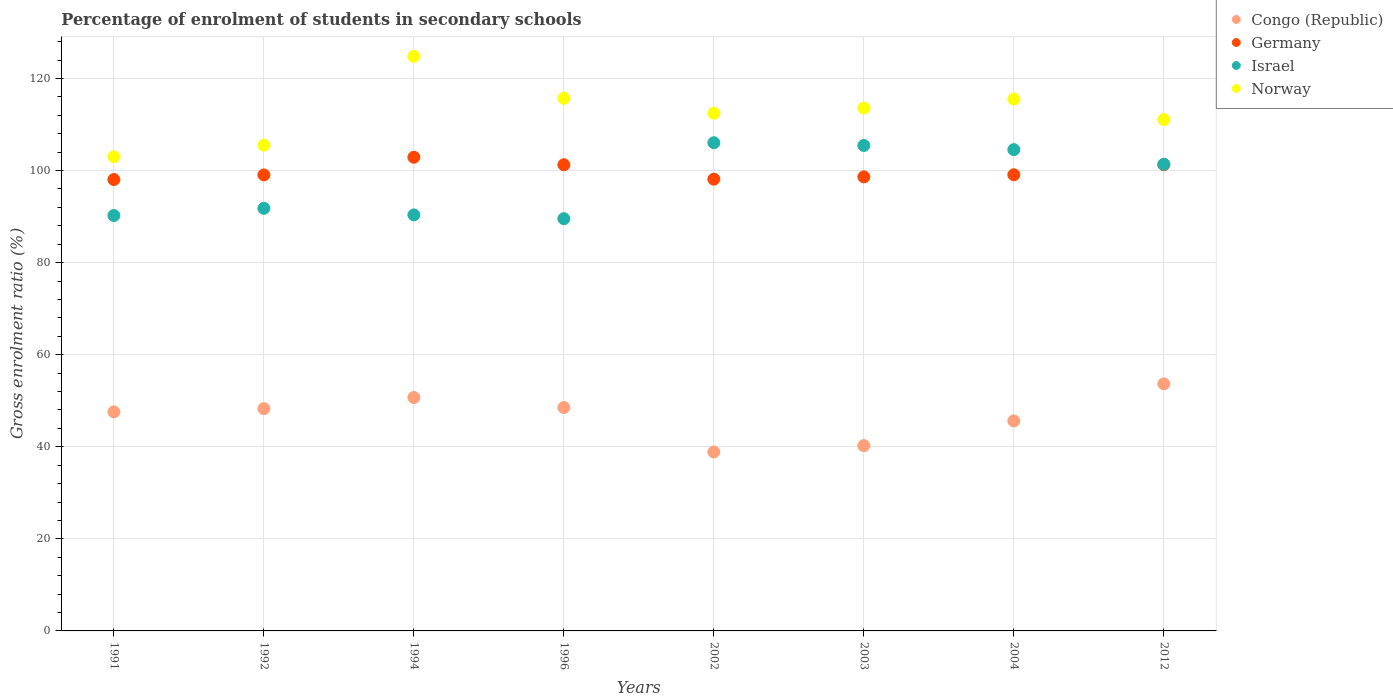What is the percentage of students enrolled in secondary schools in Germany in 1991?
Provide a succinct answer. 98.04. Across all years, what is the maximum percentage of students enrolled in secondary schools in Norway?
Offer a terse response. 124.79. Across all years, what is the minimum percentage of students enrolled in secondary schools in Congo (Republic)?
Make the answer very short. 38.87. In which year was the percentage of students enrolled in secondary schools in Israel minimum?
Make the answer very short. 1996. What is the total percentage of students enrolled in secondary schools in Congo (Republic) in the graph?
Make the answer very short. 373.46. What is the difference between the percentage of students enrolled in secondary schools in Germany in 2004 and that in 2012?
Ensure brevity in your answer.  -2.19. What is the difference between the percentage of students enrolled in secondary schools in Israel in 2004 and the percentage of students enrolled in secondary schools in Norway in 2012?
Provide a short and direct response. -6.53. What is the average percentage of students enrolled in secondary schools in Congo (Republic) per year?
Ensure brevity in your answer.  46.68. In the year 1992, what is the difference between the percentage of students enrolled in secondary schools in Norway and percentage of students enrolled in secondary schools in Germany?
Your answer should be very brief. 6.47. What is the ratio of the percentage of students enrolled in secondary schools in Congo (Republic) in 1991 to that in 1996?
Provide a short and direct response. 0.98. Is the percentage of students enrolled in secondary schools in Germany in 1991 less than that in 2003?
Provide a short and direct response. Yes. What is the difference between the highest and the second highest percentage of students enrolled in secondary schools in Germany?
Keep it short and to the point. 1.61. What is the difference between the highest and the lowest percentage of students enrolled in secondary schools in Israel?
Your answer should be very brief. 16.5. In how many years, is the percentage of students enrolled in secondary schools in Congo (Republic) greater than the average percentage of students enrolled in secondary schools in Congo (Republic) taken over all years?
Provide a succinct answer. 5. Is the sum of the percentage of students enrolled in secondary schools in Congo (Republic) in 1994 and 2004 greater than the maximum percentage of students enrolled in secondary schools in Germany across all years?
Keep it short and to the point. No. Is it the case that in every year, the sum of the percentage of students enrolled in secondary schools in Norway and percentage of students enrolled in secondary schools in Congo (Republic)  is greater than the sum of percentage of students enrolled in secondary schools in Israel and percentage of students enrolled in secondary schools in Germany?
Your answer should be very brief. No. Is it the case that in every year, the sum of the percentage of students enrolled in secondary schools in Congo (Republic) and percentage of students enrolled in secondary schools in Germany  is greater than the percentage of students enrolled in secondary schools in Israel?
Your answer should be very brief. Yes. Does the percentage of students enrolled in secondary schools in Germany monotonically increase over the years?
Your answer should be compact. No. Is the percentage of students enrolled in secondary schools in Germany strictly greater than the percentage of students enrolled in secondary schools in Norway over the years?
Your response must be concise. No. How many legend labels are there?
Offer a very short reply. 4. What is the title of the graph?
Your answer should be very brief. Percentage of enrolment of students in secondary schools. What is the label or title of the X-axis?
Make the answer very short. Years. What is the label or title of the Y-axis?
Your answer should be compact. Gross enrolment ratio (%). What is the Gross enrolment ratio (%) in Congo (Republic) in 1991?
Make the answer very short. 47.58. What is the Gross enrolment ratio (%) in Germany in 1991?
Provide a short and direct response. 98.04. What is the Gross enrolment ratio (%) of Israel in 1991?
Offer a terse response. 90.22. What is the Gross enrolment ratio (%) of Norway in 1991?
Your response must be concise. 102.99. What is the Gross enrolment ratio (%) in Congo (Republic) in 1992?
Your answer should be very brief. 48.28. What is the Gross enrolment ratio (%) of Germany in 1992?
Keep it short and to the point. 99.04. What is the Gross enrolment ratio (%) of Israel in 1992?
Your answer should be very brief. 91.79. What is the Gross enrolment ratio (%) in Norway in 1992?
Offer a very short reply. 105.51. What is the Gross enrolment ratio (%) in Congo (Republic) in 1994?
Provide a succinct answer. 50.69. What is the Gross enrolment ratio (%) in Germany in 1994?
Keep it short and to the point. 102.88. What is the Gross enrolment ratio (%) of Israel in 1994?
Keep it short and to the point. 90.36. What is the Gross enrolment ratio (%) in Norway in 1994?
Keep it short and to the point. 124.79. What is the Gross enrolment ratio (%) in Congo (Republic) in 1996?
Your answer should be compact. 48.52. What is the Gross enrolment ratio (%) in Germany in 1996?
Make the answer very short. 101.25. What is the Gross enrolment ratio (%) in Israel in 1996?
Make the answer very short. 89.54. What is the Gross enrolment ratio (%) of Norway in 1996?
Your response must be concise. 115.7. What is the Gross enrolment ratio (%) in Congo (Republic) in 2002?
Give a very brief answer. 38.87. What is the Gross enrolment ratio (%) in Germany in 2002?
Give a very brief answer. 98.12. What is the Gross enrolment ratio (%) of Israel in 2002?
Your answer should be compact. 106.04. What is the Gross enrolment ratio (%) of Norway in 2002?
Ensure brevity in your answer.  112.43. What is the Gross enrolment ratio (%) in Congo (Republic) in 2003?
Provide a short and direct response. 40.24. What is the Gross enrolment ratio (%) of Germany in 2003?
Keep it short and to the point. 98.62. What is the Gross enrolment ratio (%) in Israel in 2003?
Keep it short and to the point. 105.44. What is the Gross enrolment ratio (%) of Norway in 2003?
Provide a succinct answer. 113.56. What is the Gross enrolment ratio (%) of Congo (Republic) in 2004?
Keep it short and to the point. 45.62. What is the Gross enrolment ratio (%) in Germany in 2004?
Provide a succinct answer. 99.07. What is the Gross enrolment ratio (%) in Israel in 2004?
Your answer should be very brief. 104.53. What is the Gross enrolment ratio (%) in Norway in 2004?
Provide a short and direct response. 115.52. What is the Gross enrolment ratio (%) of Congo (Republic) in 2012?
Keep it short and to the point. 53.66. What is the Gross enrolment ratio (%) of Germany in 2012?
Give a very brief answer. 101.27. What is the Gross enrolment ratio (%) of Israel in 2012?
Ensure brevity in your answer.  101.36. What is the Gross enrolment ratio (%) in Norway in 2012?
Your answer should be very brief. 111.06. Across all years, what is the maximum Gross enrolment ratio (%) in Congo (Republic)?
Make the answer very short. 53.66. Across all years, what is the maximum Gross enrolment ratio (%) of Germany?
Your response must be concise. 102.88. Across all years, what is the maximum Gross enrolment ratio (%) in Israel?
Keep it short and to the point. 106.04. Across all years, what is the maximum Gross enrolment ratio (%) of Norway?
Provide a succinct answer. 124.79. Across all years, what is the minimum Gross enrolment ratio (%) of Congo (Republic)?
Give a very brief answer. 38.87. Across all years, what is the minimum Gross enrolment ratio (%) of Germany?
Your response must be concise. 98.04. Across all years, what is the minimum Gross enrolment ratio (%) of Israel?
Give a very brief answer. 89.54. Across all years, what is the minimum Gross enrolment ratio (%) of Norway?
Keep it short and to the point. 102.99. What is the total Gross enrolment ratio (%) of Congo (Republic) in the graph?
Your answer should be compact. 373.46. What is the total Gross enrolment ratio (%) in Germany in the graph?
Keep it short and to the point. 798.29. What is the total Gross enrolment ratio (%) of Israel in the graph?
Offer a terse response. 779.27. What is the total Gross enrolment ratio (%) of Norway in the graph?
Provide a succinct answer. 901.56. What is the difference between the Gross enrolment ratio (%) of Congo (Republic) in 1991 and that in 1992?
Your answer should be compact. -0.7. What is the difference between the Gross enrolment ratio (%) of Germany in 1991 and that in 1992?
Offer a terse response. -1. What is the difference between the Gross enrolment ratio (%) in Israel in 1991 and that in 1992?
Your answer should be compact. -1.56. What is the difference between the Gross enrolment ratio (%) of Norway in 1991 and that in 1992?
Your response must be concise. -2.52. What is the difference between the Gross enrolment ratio (%) in Congo (Republic) in 1991 and that in 1994?
Provide a succinct answer. -3.12. What is the difference between the Gross enrolment ratio (%) of Germany in 1991 and that in 1994?
Give a very brief answer. -4.84. What is the difference between the Gross enrolment ratio (%) in Israel in 1991 and that in 1994?
Give a very brief answer. -0.13. What is the difference between the Gross enrolment ratio (%) of Norway in 1991 and that in 1994?
Make the answer very short. -21.81. What is the difference between the Gross enrolment ratio (%) of Congo (Republic) in 1991 and that in 1996?
Your answer should be compact. -0.95. What is the difference between the Gross enrolment ratio (%) in Germany in 1991 and that in 1996?
Your answer should be compact. -3.21. What is the difference between the Gross enrolment ratio (%) of Israel in 1991 and that in 1996?
Make the answer very short. 0.68. What is the difference between the Gross enrolment ratio (%) in Norway in 1991 and that in 1996?
Offer a terse response. -12.71. What is the difference between the Gross enrolment ratio (%) of Congo (Republic) in 1991 and that in 2002?
Offer a terse response. 8.7. What is the difference between the Gross enrolment ratio (%) of Germany in 1991 and that in 2002?
Make the answer very short. -0.08. What is the difference between the Gross enrolment ratio (%) in Israel in 1991 and that in 2002?
Provide a short and direct response. -15.81. What is the difference between the Gross enrolment ratio (%) in Norway in 1991 and that in 2002?
Keep it short and to the point. -9.44. What is the difference between the Gross enrolment ratio (%) of Congo (Republic) in 1991 and that in 2003?
Ensure brevity in your answer.  7.34. What is the difference between the Gross enrolment ratio (%) in Germany in 1991 and that in 2003?
Your answer should be very brief. -0.58. What is the difference between the Gross enrolment ratio (%) of Israel in 1991 and that in 2003?
Offer a very short reply. -15.22. What is the difference between the Gross enrolment ratio (%) of Norway in 1991 and that in 2003?
Offer a terse response. -10.57. What is the difference between the Gross enrolment ratio (%) in Congo (Republic) in 1991 and that in 2004?
Your answer should be compact. 1.96. What is the difference between the Gross enrolment ratio (%) of Germany in 1991 and that in 2004?
Ensure brevity in your answer.  -1.03. What is the difference between the Gross enrolment ratio (%) of Israel in 1991 and that in 2004?
Provide a succinct answer. -14.31. What is the difference between the Gross enrolment ratio (%) in Norway in 1991 and that in 2004?
Your answer should be compact. -12.53. What is the difference between the Gross enrolment ratio (%) in Congo (Republic) in 1991 and that in 2012?
Your response must be concise. -6.09. What is the difference between the Gross enrolment ratio (%) of Germany in 1991 and that in 2012?
Provide a short and direct response. -3.23. What is the difference between the Gross enrolment ratio (%) in Israel in 1991 and that in 2012?
Provide a succinct answer. -11.13. What is the difference between the Gross enrolment ratio (%) of Norway in 1991 and that in 2012?
Your answer should be very brief. -8.07. What is the difference between the Gross enrolment ratio (%) in Congo (Republic) in 1992 and that in 1994?
Give a very brief answer. -2.41. What is the difference between the Gross enrolment ratio (%) of Germany in 1992 and that in 1994?
Offer a terse response. -3.84. What is the difference between the Gross enrolment ratio (%) of Israel in 1992 and that in 1994?
Offer a very short reply. 1.43. What is the difference between the Gross enrolment ratio (%) in Norway in 1992 and that in 1994?
Offer a terse response. -19.28. What is the difference between the Gross enrolment ratio (%) of Congo (Republic) in 1992 and that in 1996?
Your answer should be compact. -0.25. What is the difference between the Gross enrolment ratio (%) of Germany in 1992 and that in 1996?
Offer a very short reply. -2.21. What is the difference between the Gross enrolment ratio (%) in Israel in 1992 and that in 1996?
Give a very brief answer. 2.24. What is the difference between the Gross enrolment ratio (%) in Norway in 1992 and that in 1996?
Make the answer very short. -10.18. What is the difference between the Gross enrolment ratio (%) of Congo (Republic) in 1992 and that in 2002?
Provide a short and direct response. 9.41. What is the difference between the Gross enrolment ratio (%) in Germany in 1992 and that in 2002?
Ensure brevity in your answer.  0.92. What is the difference between the Gross enrolment ratio (%) in Israel in 1992 and that in 2002?
Provide a succinct answer. -14.25. What is the difference between the Gross enrolment ratio (%) of Norway in 1992 and that in 2002?
Offer a very short reply. -6.92. What is the difference between the Gross enrolment ratio (%) of Congo (Republic) in 1992 and that in 2003?
Your answer should be very brief. 8.04. What is the difference between the Gross enrolment ratio (%) in Germany in 1992 and that in 2003?
Your answer should be compact. 0.43. What is the difference between the Gross enrolment ratio (%) of Israel in 1992 and that in 2003?
Offer a very short reply. -13.65. What is the difference between the Gross enrolment ratio (%) in Norway in 1992 and that in 2003?
Your response must be concise. -8.05. What is the difference between the Gross enrolment ratio (%) in Congo (Republic) in 1992 and that in 2004?
Provide a short and direct response. 2.66. What is the difference between the Gross enrolment ratio (%) of Germany in 1992 and that in 2004?
Your answer should be very brief. -0.03. What is the difference between the Gross enrolment ratio (%) of Israel in 1992 and that in 2004?
Provide a short and direct response. -12.75. What is the difference between the Gross enrolment ratio (%) of Norway in 1992 and that in 2004?
Keep it short and to the point. -10. What is the difference between the Gross enrolment ratio (%) of Congo (Republic) in 1992 and that in 2012?
Make the answer very short. -5.38. What is the difference between the Gross enrolment ratio (%) of Germany in 1992 and that in 2012?
Your response must be concise. -2.22. What is the difference between the Gross enrolment ratio (%) in Israel in 1992 and that in 2012?
Your answer should be compact. -9.57. What is the difference between the Gross enrolment ratio (%) of Norway in 1992 and that in 2012?
Ensure brevity in your answer.  -5.55. What is the difference between the Gross enrolment ratio (%) in Congo (Republic) in 1994 and that in 1996?
Ensure brevity in your answer.  2.17. What is the difference between the Gross enrolment ratio (%) in Germany in 1994 and that in 1996?
Your answer should be compact. 1.63. What is the difference between the Gross enrolment ratio (%) in Israel in 1994 and that in 1996?
Your response must be concise. 0.81. What is the difference between the Gross enrolment ratio (%) of Norway in 1994 and that in 1996?
Make the answer very short. 9.1. What is the difference between the Gross enrolment ratio (%) in Congo (Republic) in 1994 and that in 2002?
Give a very brief answer. 11.82. What is the difference between the Gross enrolment ratio (%) in Germany in 1994 and that in 2002?
Offer a very short reply. 4.76. What is the difference between the Gross enrolment ratio (%) of Israel in 1994 and that in 2002?
Offer a very short reply. -15.68. What is the difference between the Gross enrolment ratio (%) of Norway in 1994 and that in 2002?
Make the answer very short. 12.37. What is the difference between the Gross enrolment ratio (%) in Congo (Republic) in 1994 and that in 2003?
Offer a very short reply. 10.46. What is the difference between the Gross enrolment ratio (%) in Germany in 1994 and that in 2003?
Offer a very short reply. 4.26. What is the difference between the Gross enrolment ratio (%) of Israel in 1994 and that in 2003?
Provide a short and direct response. -15.08. What is the difference between the Gross enrolment ratio (%) of Norway in 1994 and that in 2003?
Keep it short and to the point. 11.23. What is the difference between the Gross enrolment ratio (%) in Congo (Republic) in 1994 and that in 2004?
Your response must be concise. 5.08. What is the difference between the Gross enrolment ratio (%) of Germany in 1994 and that in 2004?
Ensure brevity in your answer.  3.81. What is the difference between the Gross enrolment ratio (%) in Israel in 1994 and that in 2004?
Provide a short and direct response. -14.18. What is the difference between the Gross enrolment ratio (%) in Norway in 1994 and that in 2004?
Ensure brevity in your answer.  9.28. What is the difference between the Gross enrolment ratio (%) in Congo (Republic) in 1994 and that in 2012?
Your answer should be very brief. -2.97. What is the difference between the Gross enrolment ratio (%) in Germany in 1994 and that in 2012?
Give a very brief answer. 1.61. What is the difference between the Gross enrolment ratio (%) in Israel in 1994 and that in 2012?
Provide a succinct answer. -11. What is the difference between the Gross enrolment ratio (%) of Norway in 1994 and that in 2012?
Your answer should be very brief. 13.73. What is the difference between the Gross enrolment ratio (%) in Congo (Republic) in 1996 and that in 2002?
Make the answer very short. 9.65. What is the difference between the Gross enrolment ratio (%) of Germany in 1996 and that in 2002?
Provide a succinct answer. 3.13. What is the difference between the Gross enrolment ratio (%) of Israel in 1996 and that in 2002?
Your answer should be compact. -16.5. What is the difference between the Gross enrolment ratio (%) in Norway in 1996 and that in 2002?
Provide a short and direct response. 3.27. What is the difference between the Gross enrolment ratio (%) of Congo (Republic) in 1996 and that in 2003?
Provide a succinct answer. 8.29. What is the difference between the Gross enrolment ratio (%) of Germany in 1996 and that in 2003?
Provide a succinct answer. 2.63. What is the difference between the Gross enrolment ratio (%) in Israel in 1996 and that in 2003?
Your answer should be compact. -15.9. What is the difference between the Gross enrolment ratio (%) of Norway in 1996 and that in 2003?
Offer a terse response. 2.13. What is the difference between the Gross enrolment ratio (%) of Congo (Republic) in 1996 and that in 2004?
Provide a short and direct response. 2.91. What is the difference between the Gross enrolment ratio (%) of Germany in 1996 and that in 2004?
Provide a succinct answer. 2.18. What is the difference between the Gross enrolment ratio (%) in Israel in 1996 and that in 2004?
Your answer should be compact. -14.99. What is the difference between the Gross enrolment ratio (%) in Norway in 1996 and that in 2004?
Ensure brevity in your answer.  0.18. What is the difference between the Gross enrolment ratio (%) in Congo (Republic) in 1996 and that in 2012?
Your answer should be very brief. -5.14. What is the difference between the Gross enrolment ratio (%) in Germany in 1996 and that in 2012?
Your answer should be very brief. -0.02. What is the difference between the Gross enrolment ratio (%) in Israel in 1996 and that in 2012?
Keep it short and to the point. -11.82. What is the difference between the Gross enrolment ratio (%) of Norway in 1996 and that in 2012?
Keep it short and to the point. 4.63. What is the difference between the Gross enrolment ratio (%) in Congo (Republic) in 2002 and that in 2003?
Your answer should be very brief. -1.37. What is the difference between the Gross enrolment ratio (%) in Germany in 2002 and that in 2003?
Make the answer very short. -0.49. What is the difference between the Gross enrolment ratio (%) of Israel in 2002 and that in 2003?
Offer a terse response. 0.6. What is the difference between the Gross enrolment ratio (%) of Norway in 2002 and that in 2003?
Your answer should be very brief. -1.13. What is the difference between the Gross enrolment ratio (%) of Congo (Republic) in 2002 and that in 2004?
Ensure brevity in your answer.  -6.74. What is the difference between the Gross enrolment ratio (%) in Germany in 2002 and that in 2004?
Keep it short and to the point. -0.95. What is the difference between the Gross enrolment ratio (%) of Israel in 2002 and that in 2004?
Provide a short and direct response. 1.51. What is the difference between the Gross enrolment ratio (%) in Norway in 2002 and that in 2004?
Give a very brief answer. -3.09. What is the difference between the Gross enrolment ratio (%) of Congo (Republic) in 2002 and that in 2012?
Your response must be concise. -14.79. What is the difference between the Gross enrolment ratio (%) of Germany in 2002 and that in 2012?
Offer a terse response. -3.14. What is the difference between the Gross enrolment ratio (%) of Israel in 2002 and that in 2012?
Provide a succinct answer. 4.68. What is the difference between the Gross enrolment ratio (%) in Norway in 2002 and that in 2012?
Your answer should be compact. 1.37. What is the difference between the Gross enrolment ratio (%) in Congo (Republic) in 2003 and that in 2004?
Provide a succinct answer. -5.38. What is the difference between the Gross enrolment ratio (%) of Germany in 2003 and that in 2004?
Make the answer very short. -0.46. What is the difference between the Gross enrolment ratio (%) of Norway in 2003 and that in 2004?
Your answer should be compact. -1.96. What is the difference between the Gross enrolment ratio (%) in Congo (Republic) in 2003 and that in 2012?
Keep it short and to the point. -13.43. What is the difference between the Gross enrolment ratio (%) in Germany in 2003 and that in 2012?
Keep it short and to the point. -2.65. What is the difference between the Gross enrolment ratio (%) in Israel in 2003 and that in 2012?
Offer a terse response. 4.08. What is the difference between the Gross enrolment ratio (%) in Norway in 2003 and that in 2012?
Your response must be concise. 2.5. What is the difference between the Gross enrolment ratio (%) of Congo (Republic) in 2004 and that in 2012?
Your answer should be very brief. -8.05. What is the difference between the Gross enrolment ratio (%) in Germany in 2004 and that in 2012?
Offer a very short reply. -2.19. What is the difference between the Gross enrolment ratio (%) in Israel in 2004 and that in 2012?
Keep it short and to the point. 3.17. What is the difference between the Gross enrolment ratio (%) in Norway in 2004 and that in 2012?
Your response must be concise. 4.46. What is the difference between the Gross enrolment ratio (%) in Congo (Republic) in 1991 and the Gross enrolment ratio (%) in Germany in 1992?
Make the answer very short. -51.47. What is the difference between the Gross enrolment ratio (%) in Congo (Republic) in 1991 and the Gross enrolment ratio (%) in Israel in 1992?
Keep it short and to the point. -44.21. What is the difference between the Gross enrolment ratio (%) of Congo (Republic) in 1991 and the Gross enrolment ratio (%) of Norway in 1992?
Offer a terse response. -57.94. What is the difference between the Gross enrolment ratio (%) in Germany in 1991 and the Gross enrolment ratio (%) in Israel in 1992?
Provide a succinct answer. 6.26. What is the difference between the Gross enrolment ratio (%) in Germany in 1991 and the Gross enrolment ratio (%) in Norway in 1992?
Ensure brevity in your answer.  -7.47. What is the difference between the Gross enrolment ratio (%) of Israel in 1991 and the Gross enrolment ratio (%) of Norway in 1992?
Provide a short and direct response. -15.29. What is the difference between the Gross enrolment ratio (%) of Congo (Republic) in 1991 and the Gross enrolment ratio (%) of Germany in 1994?
Your answer should be very brief. -55.3. What is the difference between the Gross enrolment ratio (%) in Congo (Republic) in 1991 and the Gross enrolment ratio (%) in Israel in 1994?
Offer a terse response. -42.78. What is the difference between the Gross enrolment ratio (%) in Congo (Republic) in 1991 and the Gross enrolment ratio (%) in Norway in 1994?
Provide a short and direct response. -77.22. What is the difference between the Gross enrolment ratio (%) in Germany in 1991 and the Gross enrolment ratio (%) in Israel in 1994?
Ensure brevity in your answer.  7.69. What is the difference between the Gross enrolment ratio (%) in Germany in 1991 and the Gross enrolment ratio (%) in Norway in 1994?
Provide a short and direct response. -26.75. What is the difference between the Gross enrolment ratio (%) of Israel in 1991 and the Gross enrolment ratio (%) of Norway in 1994?
Provide a succinct answer. -34.57. What is the difference between the Gross enrolment ratio (%) of Congo (Republic) in 1991 and the Gross enrolment ratio (%) of Germany in 1996?
Keep it short and to the point. -53.67. What is the difference between the Gross enrolment ratio (%) in Congo (Republic) in 1991 and the Gross enrolment ratio (%) in Israel in 1996?
Offer a terse response. -41.97. What is the difference between the Gross enrolment ratio (%) in Congo (Republic) in 1991 and the Gross enrolment ratio (%) in Norway in 1996?
Make the answer very short. -68.12. What is the difference between the Gross enrolment ratio (%) in Germany in 1991 and the Gross enrolment ratio (%) in Israel in 1996?
Make the answer very short. 8.5. What is the difference between the Gross enrolment ratio (%) of Germany in 1991 and the Gross enrolment ratio (%) of Norway in 1996?
Ensure brevity in your answer.  -17.65. What is the difference between the Gross enrolment ratio (%) in Israel in 1991 and the Gross enrolment ratio (%) in Norway in 1996?
Give a very brief answer. -25.47. What is the difference between the Gross enrolment ratio (%) of Congo (Republic) in 1991 and the Gross enrolment ratio (%) of Germany in 2002?
Make the answer very short. -50.55. What is the difference between the Gross enrolment ratio (%) of Congo (Republic) in 1991 and the Gross enrolment ratio (%) of Israel in 2002?
Ensure brevity in your answer.  -58.46. What is the difference between the Gross enrolment ratio (%) of Congo (Republic) in 1991 and the Gross enrolment ratio (%) of Norway in 2002?
Give a very brief answer. -64.85. What is the difference between the Gross enrolment ratio (%) of Germany in 1991 and the Gross enrolment ratio (%) of Israel in 2002?
Offer a terse response. -8. What is the difference between the Gross enrolment ratio (%) in Germany in 1991 and the Gross enrolment ratio (%) in Norway in 2002?
Keep it short and to the point. -14.39. What is the difference between the Gross enrolment ratio (%) in Israel in 1991 and the Gross enrolment ratio (%) in Norway in 2002?
Your response must be concise. -22.2. What is the difference between the Gross enrolment ratio (%) in Congo (Republic) in 1991 and the Gross enrolment ratio (%) in Germany in 2003?
Your response must be concise. -51.04. What is the difference between the Gross enrolment ratio (%) in Congo (Republic) in 1991 and the Gross enrolment ratio (%) in Israel in 2003?
Offer a very short reply. -57.86. What is the difference between the Gross enrolment ratio (%) in Congo (Republic) in 1991 and the Gross enrolment ratio (%) in Norway in 2003?
Offer a very short reply. -65.99. What is the difference between the Gross enrolment ratio (%) in Germany in 1991 and the Gross enrolment ratio (%) in Israel in 2003?
Your answer should be compact. -7.4. What is the difference between the Gross enrolment ratio (%) in Germany in 1991 and the Gross enrolment ratio (%) in Norway in 2003?
Your response must be concise. -15.52. What is the difference between the Gross enrolment ratio (%) of Israel in 1991 and the Gross enrolment ratio (%) of Norway in 2003?
Your response must be concise. -23.34. What is the difference between the Gross enrolment ratio (%) of Congo (Republic) in 1991 and the Gross enrolment ratio (%) of Germany in 2004?
Provide a succinct answer. -51.5. What is the difference between the Gross enrolment ratio (%) in Congo (Republic) in 1991 and the Gross enrolment ratio (%) in Israel in 2004?
Provide a short and direct response. -56.96. What is the difference between the Gross enrolment ratio (%) of Congo (Republic) in 1991 and the Gross enrolment ratio (%) of Norway in 2004?
Provide a succinct answer. -67.94. What is the difference between the Gross enrolment ratio (%) of Germany in 1991 and the Gross enrolment ratio (%) of Israel in 2004?
Ensure brevity in your answer.  -6.49. What is the difference between the Gross enrolment ratio (%) of Germany in 1991 and the Gross enrolment ratio (%) of Norway in 2004?
Offer a terse response. -17.48. What is the difference between the Gross enrolment ratio (%) of Israel in 1991 and the Gross enrolment ratio (%) of Norway in 2004?
Give a very brief answer. -25.29. What is the difference between the Gross enrolment ratio (%) of Congo (Republic) in 1991 and the Gross enrolment ratio (%) of Germany in 2012?
Ensure brevity in your answer.  -53.69. What is the difference between the Gross enrolment ratio (%) in Congo (Republic) in 1991 and the Gross enrolment ratio (%) in Israel in 2012?
Provide a succinct answer. -53.78. What is the difference between the Gross enrolment ratio (%) in Congo (Republic) in 1991 and the Gross enrolment ratio (%) in Norway in 2012?
Your answer should be compact. -63.49. What is the difference between the Gross enrolment ratio (%) in Germany in 1991 and the Gross enrolment ratio (%) in Israel in 2012?
Your answer should be very brief. -3.32. What is the difference between the Gross enrolment ratio (%) in Germany in 1991 and the Gross enrolment ratio (%) in Norway in 2012?
Offer a terse response. -13.02. What is the difference between the Gross enrolment ratio (%) in Israel in 1991 and the Gross enrolment ratio (%) in Norway in 2012?
Offer a terse response. -20.84. What is the difference between the Gross enrolment ratio (%) of Congo (Republic) in 1992 and the Gross enrolment ratio (%) of Germany in 1994?
Provide a succinct answer. -54.6. What is the difference between the Gross enrolment ratio (%) in Congo (Republic) in 1992 and the Gross enrolment ratio (%) in Israel in 1994?
Ensure brevity in your answer.  -42.08. What is the difference between the Gross enrolment ratio (%) in Congo (Republic) in 1992 and the Gross enrolment ratio (%) in Norway in 1994?
Offer a very short reply. -76.51. What is the difference between the Gross enrolment ratio (%) in Germany in 1992 and the Gross enrolment ratio (%) in Israel in 1994?
Keep it short and to the point. 8.69. What is the difference between the Gross enrolment ratio (%) of Germany in 1992 and the Gross enrolment ratio (%) of Norway in 1994?
Make the answer very short. -25.75. What is the difference between the Gross enrolment ratio (%) in Israel in 1992 and the Gross enrolment ratio (%) in Norway in 1994?
Ensure brevity in your answer.  -33.01. What is the difference between the Gross enrolment ratio (%) of Congo (Republic) in 1992 and the Gross enrolment ratio (%) of Germany in 1996?
Offer a terse response. -52.97. What is the difference between the Gross enrolment ratio (%) of Congo (Republic) in 1992 and the Gross enrolment ratio (%) of Israel in 1996?
Provide a short and direct response. -41.26. What is the difference between the Gross enrolment ratio (%) in Congo (Republic) in 1992 and the Gross enrolment ratio (%) in Norway in 1996?
Offer a terse response. -67.42. What is the difference between the Gross enrolment ratio (%) in Germany in 1992 and the Gross enrolment ratio (%) in Israel in 1996?
Make the answer very short. 9.5. What is the difference between the Gross enrolment ratio (%) of Germany in 1992 and the Gross enrolment ratio (%) of Norway in 1996?
Provide a short and direct response. -16.65. What is the difference between the Gross enrolment ratio (%) in Israel in 1992 and the Gross enrolment ratio (%) in Norway in 1996?
Make the answer very short. -23.91. What is the difference between the Gross enrolment ratio (%) of Congo (Republic) in 1992 and the Gross enrolment ratio (%) of Germany in 2002?
Your answer should be very brief. -49.84. What is the difference between the Gross enrolment ratio (%) in Congo (Republic) in 1992 and the Gross enrolment ratio (%) in Israel in 2002?
Offer a very short reply. -57.76. What is the difference between the Gross enrolment ratio (%) in Congo (Republic) in 1992 and the Gross enrolment ratio (%) in Norway in 2002?
Offer a terse response. -64.15. What is the difference between the Gross enrolment ratio (%) of Germany in 1992 and the Gross enrolment ratio (%) of Israel in 2002?
Make the answer very short. -6.99. What is the difference between the Gross enrolment ratio (%) of Germany in 1992 and the Gross enrolment ratio (%) of Norway in 2002?
Offer a very short reply. -13.39. What is the difference between the Gross enrolment ratio (%) in Israel in 1992 and the Gross enrolment ratio (%) in Norway in 2002?
Your response must be concise. -20.64. What is the difference between the Gross enrolment ratio (%) of Congo (Republic) in 1992 and the Gross enrolment ratio (%) of Germany in 2003?
Keep it short and to the point. -50.34. What is the difference between the Gross enrolment ratio (%) in Congo (Republic) in 1992 and the Gross enrolment ratio (%) in Israel in 2003?
Offer a terse response. -57.16. What is the difference between the Gross enrolment ratio (%) of Congo (Republic) in 1992 and the Gross enrolment ratio (%) of Norway in 2003?
Provide a short and direct response. -65.28. What is the difference between the Gross enrolment ratio (%) of Germany in 1992 and the Gross enrolment ratio (%) of Israel in 2003?
Your answer should be compact. -6.4. What is the difference between the Gross enrolment ratio (%) in Germany in 1992 and the Gross enrolment ratio (%) in Norway in 2003?
Keep it short and to the point. -14.52. What is the difference between the Gross enrolment ratio (%) of Israel in 1992 and the Gross enrolment ratio (%) of Norway in 2003?
Your answer should be very brief. -21.78. What is the difference between the Gross enrolment ratio (%) of Congo (Republic) in 1992 and the Gross enrolment ratio (%) of Germany in 2004?
Ensure brevity in your answer.  -50.79. What is the difference between the Gross enrolment ratio (%) in Congo (Republic) in 1992 and the Gross enrolment ratio (%) in Israel in 2004?
Offer a terse response. -56.25. What is the difference between the Gross enrolment ratio (%) in Congo (Republic) in 1992 and the Gross enrolment ratio (%) in Norway in 2004?
Your answer should be very brief. -67.24. What is the difference between the Gross enrolment ratio (%) of Germany in 1992 and the Gross enrolment ratio (%) of Israel in 2004?
Your answer should be very brief. -5.49. What is the difference between the Gross enrolment ratio (%) of Germany in 1992 and the Gross enrolment ratio (%) of Norway in 2004?
Provide a succinct answer. -16.47. What is the difference between the Gross enrolment ratio (%) of Israel in 1992 and the Gross enrolment ratio (%) of Norway in 2004?
Make the answer very short. -23.73. What is the difference between the Gross enrolment ratio (%) of Congo (Republic) in 1992 and the Gross enrolment ratio (%) of Germany in 2012?
Keep it short and to the point. -52.99. What is the difference between the Gross enrolment ratio (%) in Congo (Republic) in 1992 and the Gross enrolment ratio (%) in Israel in 2012?
Provide a succinct answer. -53.08. What is the difference between the Gross enrolment ratio (%) of Congo (Republic) in 1992 and the Gross enrolment ratio (%) of Norway in 2012?
Your answer should be very brief. -62.78. What is the difference between the Gross enrolment ratio (%) of Germany in 1992 and the Gross enrolment ratio (%) of Israel in 2012?
Provide a short and direct response. -2.31. What is the difference between the Gross enrolment ratio (%) in Germany in 1992 and the Gross enrolment ratio (%) in Norway in 2012?
Your answer should be very brief. -12.02. What is the difference between the Gross enrolment ratio (%) in Israel in 1992 and the Gross enrolment ratio (%) in Norway in 2012?
Ensure brevity in your answer.  -19.28. What is the difference between the Gross enrolment ratio (%) of Congo (Republic) in 1994 and the Gross enrolment ratio (%) of Germany in 1996?
Keep it short and to the point. -50.56. What is the difference between the Gross enrolment ratio (%) in Congo (Republic) in 1994 and the Gross enrolment ratio (%) in Israel in 1996?
Offer a terse response. -38.85. What is the difference between the Gross enrolment ratio (%) of Congo (Republic) in 1994 and the Gross enrolment ratio (%) of Norway in 1996?
Offer a terse response. -65. What is the difference between the Gross enrolment ratio (%) of Germany in 1994 and the Gross enrolment ratio (%) of Israel in 1996?
Keep it short and to the point. 13.34. What is the difference between the Gross enrolment ratio (%) in Germany in 1994 and the Gross enrolment ratio (%) in Norway in 1996?
Your answer should be very brief. -12.82. What is the difference between the Gross enrolment ratio (%) of Israel in 1994 and the Gross enrolment ratio (%) of Norway in 1996?
Provide a short and direct response. -25.34. What is the difference between the Gross enrolment ratio (%) of Congo (Republic) in 1994 and the Gross enrolment ratio (%) of Germany in 2002?
Your answer should be very brief. -47.43. What is the difference between the Gross enrolment ratio (%) in Congo (Republic) in 1994 and the Gross enrolment ratio (%) in Israel in 2002?
Provide a succinct answer. -55.34. What is the difference between the Gross enrolment ratio (%) in Congo (Republic) in 1994 and the Gross enrolment ratio (%) in Norway in 2002?
Ensure brevity in your answer.  -61.73. What is the difference between the Gross enrolment ratio (%) in Germany in 1994 and the Gross enrolment ratio (%) in Israel in 2002?
Provide a short and direct response. -3.16. What is the difference between the Gross enrolment ratio (%) of Germany in 1994 and the Gross enrolment ratio (%) of Norway in 2002?
Your response must be concise. -9.55. What is the difference between the Gross enrolment ratio (%) of Israel in 1994 and the Gross enrolment ratio (%) of Norway in 2002?
Your response must be concise. -22.07. What is the difference between the Gross enrolment ratio (%) in Congo (Republic) in 1994 and the Gross enrolment ratio (%) in Germany in 2003?
Provide a short and direct response. -47.92. What is the difference between the Gross enrolment ratio (%) in Congo (Republic) in 1994 and the Gross enrolment ratio (%) in Israel in 2003?
Offer a terse response. -54.75. What is the difference between the Gross enrolment ratio (%) of Congo (Republic) in 1994 and the Gross enrolment ratio (%) of Norway in 2003?
Offer a very short reply. -62.87. What is the difference between the Gross enrolment ratio (%) in Germany in 1994 and the Gross enrolment ratio (%) in Israel in 2003?
Make the answer very short. -2.56. What is the difference between the Gross enrolment ratio (%) in Germany in 1994 and the Gross enrolment ratio (%) in Norway in 2003?
Provide a short and direct response. -10.68. What is the difference between the Gross enrolment ratio (%) in Israel in 1994 and the Gross enrolment ratio (%) in Norway in 2003?
Keep it short and to the point. -23.21. What is the difference between the Gross enrolment ratio (%) in Congo (Republic) in 1994 and the Gross enrolment ratio (%) in Germany in 2004?
Make the answer very short. -48.38. What is the difference between the Gross enrolment ratio (%) in Congo (Republic) in 1994 and the Gross enrolment ratio (%) in Israel in 2004?
Offer a very short reply. -53.84. What is the difference between the Gross enrolment ratio (%) of Congo (Republic) in 1994 and the Gross enrolment ratio (%) of Norway in 2004?
Your answer should be very brief. -64.82. What is the difference between the Gross enrolment ratio (%) in Germany in 1994 and the Gross enrolment ratio (%) in Israel in 2004?
Provide a short and direct response. -1.65. What is the difference between the Gross enrolment ratio (%) of Germany in 1994 and the Gross enrolment ratio (%) of Norway in 2004?
Provide a succinct answer. -12.64. What is the difference between the Gross enrolment ratio (%) in Israel in 1994 and the Gross enrolment ratio (%) in Norway in 2004?
Make the answer very short. -25.16. What is the difference between the Gross enrolment ratio (%) in Congo (Republic) in 1994 and the Gross enrolment ratio (%) in Germany in 2012?
Keep it short and to the point. -50.57. What is the difference between the Gross enrolment ratio (%) of Congo (Republic) in 1994 and the Gross enrolment ratio (%) of Israel in 2012?
Ensure brevity in your answer.  -50.66. What is the difference between the Gross enrolment ratio (%) in Congo (Republic) in 1994 and the Gross enrolment ratio (%) in Norway in 2012?
Keep it short and to the point. -60.37. What is the difference between the Gross enrolment ratio (%) of Germany in 1994 and the Gross enrolment ratio (%) of Israel in 2012?
Make the answer very short. 1.52. What is the difference between the Gross enrolment ratio (%) in Germany in 1994 and the Gross enrolment ratio (%) in Norway in 2012?
Offer a terse response. -8.18. What is the difference between the Gross enrolment ratio (%) of Israel in 1994 and the Gross enrolment ratio (%) of Norway in 2012?
Provide a succinct answer. -20.71. What is the difference between the Gross enrolment ratio (%) in Congo (Republic) in 1996 and the Gross enrolment ratio (%) in Germany in 2002?
Your answer should be compact. -49.6. What is the difference between the Gross enrolment ratio (%) of Congo (Republic) in 1996 and the Gross enrolment ratio (%) of Israel in 2002?
Provide a succinct answer. -57.51. What is the difference between the Gross enrolment ratio (%) of Congo (Republic) in 1996 and the Gross enrolment ratio (%) of Norway in 2002?
Provide a short and direct response. -63.9. What is the difference between the Gross enrolment ratio (%) of Germany in 1996 and the Gross enrolment ratio (%) of Israel in 2002?
Your answer should be compact. -4.79. What is the difference between the Gross enrolment ratio (%) in Germany in 1996 and the Gross enrolment ratio (%) in Norway in 2002?
Provide a short and direct response. -11.18. What is the difference between the Gross enrolment ratio (%) of Israel in 1996 and the Gross enrolment ratio (%) of Norway in 2002?
Offer a terse response. -22.89. What is the difference between the Gross enrolment ratio (%) of Congo (Republic) in 1996 and the Gross enrolment ratio (%) of Germany in 2003?
Your answer should be very brief. -50.09. What is the difference between the Gross enrolment ratio (%) of Congo (Republic) in 1996 and the Gross enrolment ratio (%) of Israel in 2003?
Give a very brief answer. -56.92. What is the difference between the Gross enrolment ratio (%) in Congo (Republic) in 1996 and the Gross enrolment ratio (%) in Norway in 2003?
Provide a short and direct response. -65.04. What is the difference between the Gross enrolment ratio (%) in Germany in 1996 and the Gross enrolment ratio (%) in Israel in 2003?
Provide a succinct answer. -4.19. What is the difference between the Gross enrolment ratio (%) of Germany in 1996 and the Gross enrolment ratio (%) of Norway in 2003?
Make the answer very short. -12.31. What is the difference between the Gross enrolment ratio (%) of Israel in 1996 and the Gross enrolment ratio (%) of Norway in 2003?
Your answer should be very brief. -24.02. What is the difference between the Gross enrolment ratio (%) of Congo (Republic) in 1996 and the Gross enrolment ratio (%) of Germany in 2004?
Offer a very short reply. -50.55. What is the difference between the Gross enrolment ratio (%) in Congo (Republic) in 1996 and the Gross enrolment ratio (%) in Israel in 2004?
Provide a short and direct response. -56.01. What is the difference between the Gross enrolment ratio (%) of Congo (Republic) in 1996 and the Gross enrolment ratio (%) of Norway in 2004?
Provide a succinct answer. -66.99. What is the difference between the Gross enrolment ratio (%) of Germany in 1996 and the Gross enrolment ratio (%) of Israel in 2004?
Make the answer very short. -3.28. What is the difference between the Gross enrolment ratio (%) of Germany in 1996 and the Gross enrolment ratio (%) of Norway in 2004?
Provide a succinct answer. -14.27. What is the difference between the Gross enrolment ratio (%) of Israel in 1996 and the Gross enrolment ratio (%) of Norway in 2004?
Give a very brief answer. -25.98. What is the difference between the Gross enrolment ratio (%) in Congo (Republic) in 1996 and the Gross enrolment ratio (%) in Germany in 2012?
Keep it short and to the point. -52.74. What is the difference between the Gross enrolment ratio (%) in Congo (Republic) in 1996 and the Gross enrolment ratio (%) in Israel in 2012?
Your response must be concise. -52.83. What is the difference between the Gross enrolment ratio (%) in Congo (Republic) in 1996 and the Gross enrolment ratio (%) in Norway in 2012?
Provide a succinct answer. -62.54. What is the difference between the Gross enrolment ratio (%) of Germany in 1996 and the Gross enrolment ratio (%) of Israel in 2012?
Ensure brevity in your answer.  -0.11. What is the difference between the Gross enrolment ratio (%) of Germany in 1996 and the Gross enrolment ratio (%) of Norway in 2012?
Your answer should be compact. -9.81. What is the difference between the Gross enrolment ratio (%) of Israel in 1996 and the Gross enrolment ratio (%) of Norway in 2012?
Your answer should be compact. -21.52. What is the difference between the Gross enrolment ratio (%) in Congo (Republic) in 2002 and the Gross enrolment ratio (%) in Germany in 2003?
Your answer should be very brief. -59.75. What is the difference between the Gross enrolment ratio (%) in Congo (Republic) in 2002 and the Gross enrolment ratio (%) in Israel in 2003?
Keep it short and to the point. -66.57. What is the difference between the Gross enrolment ratio (%) in Congo (Republic) in 2002 and the Gross enrolment ratio (%) in Norway in 2003?
Make the answer very short. -74.69. What is the difference between the Gross enrolment ratio (%) of Germany in 2002 and the Gross enrolment ratio (%) of Israel in 2003?
Offer a terse response. -7.32. What is the difference between the Gross enrolment ratio (%) of Germany in 2002 and the Gross enrolment ratio (%) of Norway in 2003?
Provide a succinct answer. -15.44. What is the difference between the Gross enrolment ratio (%) in Israel in 2002 and the Gross enrolment ratio (%) in Norway in 2003?
Provide a short and direct response. -7.52. What is the difference between the Gross enrolment ratio (%) of Congo (Republic) in 2002 and the Gross enrolment ratio (%) of Germany in 2004?
Ensure brevity in your answer.  -60.2. What is the difference between the Gross enrolment ratio (%) in Congo (Republic) in 2002 and the Gross enrolment ratio (%) in Israel in 2004?
Provide a succinct answer. -65.66. What is the difference between the Gross enrolment ratio (%) of Congo (Republic) in 2002 and the Gross enrolment ratio (%) of Norway in 2004?
Ensure brevity in your answer.  -76.65. What is the difference between the Gross enrolment ratio (%) in Germany in 2002 and the Gross enrolment ratio (%) in Israel in 2004?
Provide a succinct answer. -6.41. What is the difference between the Gross enrolment ratio (%) of Germany in 2002 and the Gross enrolment ratio (%) of Norway in 2004?
Make the answer very short. -17.4. What is the difference between the Gross enrolment ratio (%) of Israel in 2002 and the Gross enrolment ratio (%) of Norway in 2004?
Offer a terse response. -9.48. What is the difference between the Gross enrolment ratio (%) of Congo (Republic) in 2002 and the Gross enrolment ratio (%) of Germany in 2012?
Provide a succinct answer. -62.4. What is the difference between the Gross enrolment ratio (%) of Congo (Republic) in 2002 and the Gross enrolment ratio (%) of Israel in 2012?
Your answer should be very brief. -62.49. What is the difference between the Gross enrolment ratio (%) in Congo (Republic) in 2002 and the Gross enrolment ratio (%) in Norway in 2012?
Ensure brevity in your answer.  -72.19. What is the difference between the Gross enrolment ratio (%) in Germany in 2002 and the Gross enrolment ratio (%) in Israel in 2012?
Provide a succinct answer. -3.24. What is the difference between the Gross enrolment ratio (%) of Germany in 2002 and the Gross enrolment ratio (%) of Norway in 2012?
Provide a succinct answer. -12.94. What is the difference between the Gross enrolment ratio (%) of Israel in 2002 and the Gross enrolment ratio (%) of Norway in 2012?
Your response must be concise. -5.03. What is the difference between the Gross enrolment ratio (%) of Congo (Republic) in 2003 and the Gross enrolment ratio (%) of Germany in 2004?
Your answer should be very brief. -58.84. What is the difference between the Gross enrolment ratio (%) in Congo (Republic) in 2003 and the Gross enrolment ratio (%) in Israel in 2004?
Keep it short and to the point. -64.29. What is the difference between the Gross enrolment ratio (%) of Congo (Republic) in 2003 and the Gross enrolment ratio (%) of Norway in 2004?
Offer a terse response. -75.28. What is the difference between the Gross enrolment ratio (%) in Germany in 2003 and the Gross enrolment ratio (%) in Israel in 2004?
Make the answer very short. -5.91. What is the difference between the Gross enrolment ratio (%) of Germany in 2003 and the Gross enrolment ratio (%) of Norway in 2004?
Your answer should be compact. -16.9. What is the difference between the Gross enrolment ratio (%) in Israel in 2003 and the Gross enrolment ratio (%) in Norway in 2004?
Provide a short and direct response. -10.08. What is the difference between the Gross enrolment ratio (%) in Congo (Republic) in 2003 and the Gross enrolment ratio (%) in Germany in 2012?
Offer a very short reply. -61.03. What is the difference between the Gross enrolment ratio (%) of Congo (Republic) in 2003 and the Gross enrolment ratio (%) of Israel in 2012?
Provide a short and direct response. -61.12. What is the difference between the Gross enrolment ratio (%) in Congo (Republic) in 2003 and the Gross enrolment ratio (%) in Norway in 2012?
Offer a terse response. -70.82. What is the difference between the Gross enrolment ratio (%) of Germany in 2003 and the Gross enrolment ratio (%) of Israel in 2012?
Your response must be concise. -2.74. What is the difference between the Gross enrolment ratio (%) of Germany in 2003 and the Gross enrolment ratio (%) of Norway in 2012?
Make the answer very short. -12.44. What is the difference between the Gross enrolment ratio (%) of Israel in 2003 and the Gross enrolment ratio (%) of Norway in 2012?
Give a very brief answer. -5.62. What is the difference between the Gross enrolment ratio (%) in Congo (Republic) in 2004 and the Gross enrolment ratio (%) in Germany in 2012?
Your answer should be compact. -55.65. What is the difference between the Gross enrolment ratio (%) in Congo (Republic) in 2004 and the Gross enrolment ratio (%) in Israel in 2012?
Make the answer very short. -55.74. What is the difference between the Gross enrolment ratio (%) of Congo (Republic) in 2004 and the Gross enrolment ratio (%) of Norway in 2012?
Ensure brevity in your answer.  -65.45. What is the difference between the Gross enrolment ratio (%) of Germany in 2004 and the Gross enrolment ratio (%) of Israel in 2012?
Provide a succinct answer. -2.28. What is the difference between the Gross enrolment ratio (%) of Germany in 2004 and the Gross enrolment ratio (%) of Norway in 2012?
Offer a terse response. -11.99. What is the difference between the Gross enrolment ratio (%) in Israel in 2004 and the Gross enrolment ratio (%) in Norway in 2012?
Keep it short and to the point. -6.53. What is the average Gross enrolment ratio (%) of Congo (Republic) per year?
Offer a very short reply. 46.68. What is the average Gross enrolment ratio (%) in Germany per year?
Offer a very short reply. 99.79. What is the average Gross enrolment ratio (%) of Israel per year?
Keep it short and to the point. 97.41. What is the average Gross enrolment ratio (%) in Norway per year?
Provide a short and direct response. 112.69. In the year 1991, what is the difference between the Gross enrolment ratio (%) of Congo (Republic) and Gross enrolment ratio (%) of Germany?
Provide a succinct answer. -50.47. In the year 1991, what is the difference between the Gross enrolment ratio (%) of Congo (Republic) and Gross enrolment ratio (%) of Israel?
Make the answer very short. -42.65. In the year 1991, what is the difference between the Gross enrolment ratio (%) in Congo (Republic) and Gross enrolment ratio (%) in Norway?
Your response must be concise. -55.41. In the year 1991, what is the difference between the Gross enrolment ratio (%) in Germany and Gross enrolment ratio (%) in Israel?
Your response must be concise. 7.82. In the year 1991, what is the difference between the Gross enrolment ratio (%) of Germany and Gross enrolment ratio (%) of Norway?
Provide a short and direct response. -4.95. In the year 1991, what is the difference between the Gross enrolment ratio (%) of Israel and Gross enrolment ratio (%) of Norway?
Provide a short and direct response. -12.76. In the year 1992, what is the difference between the Gross enrolment ratio (%) in Congo (Republic) and Gross enrolment ratio (%) in Germany?
Provide a short and direct response. -50.76. In the year 1992, what is the difference between the Gross enrolment ratio (%) of Congo (Republic) and Gross enrolment ratio (%) of Israel?
Provide a short and direct response. -43.51. In the year 1992, what is the difference between the Gross enrolment ratio (%) of Congo (Republic) and Gross enrolment ratio (%) of Norway?
Provide a succinct answer. -57.23. In the year 1992, what is the difference between the Gross enrolment ratio (%) in Germany and Gross enrolment ratio (%) in Israel?
Your response must be concise. 7.26. In the year 1992, what is the difference between the Gross enrolment ratio (%) in Germany and Gross enrolment ratio (%) in Norway?
Keep it short and to the point. -6.47. In the year 1992, what is the difference between the Gross enrolment ratio (%) in Israel and Gross enrolment ratio (%) in Norway?
Your response must be concise. -13.73. In the year 1994, what is the difference between the Gross enrolment ratio (%) in Congo (Republic) and Gross enrolment ratio (%) in Germany?
Offer a very short reply. -52.19. In the year 1994, what is the difference between the Gross enrolment ratio (%) of Congo (Republic) and Gross enrolment ratio (%) of Israel?
Offer a terse response. -39.66. In the year 1994, what is the difference between the Gross enrolment ratio (%) in Congo (Republic) and Gross enrolment ratio (%) in Norway?
Offer a terse response. -74.1. In the year 1994, what is the difference between the Gross enrolment ratio (%) of Germany and Gross enrolment ratio (%) of Israel?
Ensure brevity in your answer.  12.52. In the year 1994, what is the difference between the Gross enrolment ratio (%) of Germany and Gross enrolment ratio (%) of Norway?
Provide a succinct answer. -21.91. In the year 1994, what is the difference between the Gross enrolment ratio (%) in Israel and Gross enrolment ratio (%) in Norway?
Your answer should be very brief. -34.44. In the year 1996, what is the difference between the Gross enrolment ratio (%) in Congo (Republic) and Gross enrolment ratio (%) in Germany?
Provide a short and direct response. -52.73. In the year 1996, what is the difference between the Gross enrolment ratio (%) of Congo (Republic) and Gross enrolment ratio (%) of Israel?
Give a very brief answer. -41.02. In the year 1996, what is the difference between the Gross enrolment ratio (%) in Congo (Republic) and Gross enrolment ratio (%) in Norway?
Your answer should be compact. -67.17. In the year 1996, what is the difference between the Gross enrolment ratio (%) in Germany and Gross enrolment ratio (%) in Israel?
Keep it short and to the point. 11.71. In the year 1996, what is the difference between the Gross enrolment ratio (%) in Germany and Gross enrolment ratio (%) in Norway?
Provide a short and direct response. -14.45. In the year 1996, what is the difference between the Gross enrolment ratio (%) of Israel and Gross enrolment ratio (%) of Norway?
Keep it short and to the point. -26.15. In the year 2002, what is the difference between the Gross enrolment ratio (%) of Congo (Republic) and Gross enrolment ratio (%) of Germany?
Your answer should be very brief. -59.25. In the year 2002, what is the difference between the Gross enrolment ratio (%) of Congo (Republic) and Gross enrolment ratio (%) of Israel?
Give a very brief answer. -67.17. In the year 2002, what is the difference between the Gross enrolment ratio (%) of Congo (Republic) and Gross enrolment ratio (%) of Norway?
Offer a terse response. -73.56. In the year 2002, what is the difference between the Gross enrolment ratio (%) in Germany and Gross enrolment ratio (%) in Israel?
Give a very brief answer. -7.91. In the year 2002, what is the difference between the Gross enrolment ratio (%) in Germany and Gross enrolment ratio (%) in Norway?
Make the answer very short. -14.31. In the year 2002, what is the difference between the Gross enrolment ratio (%) in Israel and Gross enrolment ratio (%) in Norway?
Your response must be concise. -6.39. In the year 2003, what is the difference between the Gross enrolment ratio (%) of Congo (Republic) and Gross enrolment ratio (%) of Germany?
Your response must be concise. -58.38. In the year 2003, what is the difference between the Gross enrolment ratio (%) in Congo (Republic) and Gross enrolment ratio (%) in Israel?
Offer a terse response. -65.2. In the year 2003, what is the difference between the Gross enrolment ratio (%) in Congo (Republic) and Gross enrolment ratio (%) in Norway?
Keep it short and to the point. -73.32. In the year 2003, what is the difference between the Gross enrolment ratio (%) in Germany and Gross enrolment ratio (%) in Israel?
Make the answer very short. -6.82. In the year 2003, what is the difference between the Gross enrolment ratio (%) of Germany and Gross enrolment ratio (%) of Norway?
Provide a short and direct response. -14.94. In the year 2003, what is the difference between the Gross enrolment ratio (%) of Israel and Gross enrolment ratio (%) of Norway?
Keep it short and to the point. -8.12. In the year 2004, what is the difference between the Gross enrolment ratio (%) of Congo (Republic) and Gross enrolment ratio (%) of Germany?
Provide a succinct answer. -53.46. In the year 2004, what is the difference between the Gross enrolment ratio (%) of Congo (Republic) and Gross enrolment ratio (%) of Israel?
Offer a very short reply. -58.92. In the year 2004, what is the difference between the Gross enrolment ratio (%) of Congo (Republic) and Gross enrolment ratio (%) of Norway?
Offer a very short reply. -69.9. In the year 2004, what is the difference between the Gross enrolment ratio (%) of Germany and Gross enrolment ratio (%) of Israel?
Provide a succinct answer. -5.46. In the year 2004, what is the difference between the Gross enrolment ratio (%) of Germany and Gross enrolment ratio (%) of Norway?
Make the answer very short. -16.44. In the year 2004, what is the difference between the Gross enrolment ratio (%) of Israel and Gross enrolment ratio (%) of Norway?
Provide a short and direct response. -10.99. In the year 2012, what is the difference between the Gross enrolment ratio (%) of Congo (Republic) and Gross enrolment ratio (%) of Germany?
Keep it short and to the point. -47.6. In the year 2012, what is the difference between the Gross enrolment ratio (%) of Congo (Republic) and Gross enrolment ratio (%) of Israel?
Your answer should be very brief. -47.69. In the year 2012, what is the difference between the Gross enrolment ratio (%) of Congo (Republic) and Gross enrolment ratio (%) of Norway?
Your answer should be compact. -57.4. In the year 2012, what is the difference between the Gross enrolment ratio (%) in Germany and Gross enrolment ratio (%) in Israel?
Offer a very short reply. -0.09. In the year 2012, what is the difference between the Gross enrolment ratio (%) in Germany and Gross enrolment ratio (%) in Norway?
Keep it short and to the point. -9.79. In the year 2012, what is the difference between the Gross enrolment ratio (%) of Israel and Gross enrolment ratio (%) of Norway?
Offer a very short reply. -9.7. What is the ratio of the Gross enrolment ratio (%) in Congo (Republic) in 1991 to that in 1992?
Provide a succinct answer. 0.99. What is the ratio of the Gross enrolment ratio (%) of Norway in 1991 to that in 1992?
Offer a very short reply. 0.98. What is the ratio of the Gross enrolment ratio (%) in Congo (Republic) in 1991 to that in 1994?
Your answer should be compact. 0.94. What is the ratio of the Gross enrolment ratio (%) of Germany in 1991 to that in 1994?
Your answer should be compact. 0.95. What is the ratio of the Gross enrolment ratio (%) in Israel in 1991 to that in 1994?
Your response must be concise. 1. What is the ratio of the Gross enrolment ratio (%) of Norway in 1991 to that in 1994?
Ensure brevity in your answer.  0.83. What is the ratio of the Gross enrolment ratio (%) in Congo (Republic) in 1991 to that in 1996?
Offer a terse response. 0.98. What is the ratio of the Gross enrolment ratio (%) of Germany in 1991 to that in 1996?
Keep it short and to the point. 0.97. What is the ratio of the Gross enrolment ratio (%) in Israel in 1991 to that in 1996?
Your answer should be very brief. 1.01. What is the ratio of the Gross enrolment ratio (%) in Norway in 1991 to that in 1996?
Your answer should be very brief. 0.89. What is the ratio of the Gross enrolment ratio (%) of Congo (Republic) in 1991 to that in 2002?
Your answer should be very brief. 1.22. What is the ratio of the Gross enrolment ratio (%) of Germany in 1991 to that in 2002?
Offer a very short reply. 1. What is the ratio of the Gross enrolment ratio (%) of Israel in 1991 to that in 2002?
Offer a terse response. 0.85. What is the ratio of the Gross enrolment ratio (%) in Norway in 1991 to that in 2002?
Your response must be concise. 0.92. What is the ratio of the Gross enrolment ratio (%) in Congo (Republic) in 1991 to that in 2003?
Make the answer very short. 1.18. What is the ratio of the Gross enrolment ratio (%) in Germany in 1991 to that in 2003?
Your answer should be very brief. 0.99. What is the ratio of the Gross enrolment ratio (%) in Israel in 1991 to that in 2003?
Offer a terse response. 0.86. What is the ratio of the Gross enrolment ratio (%) in Norway in 1991 to that in 2003?
Offer a terse response. 0.91. What is the ratio of the Gross enrolment ratio (%) of Congo (Republic) in 1991 to that in 2004?
Make the answer very short. 1.04. What is the ratio of the Gross enrolment ratio (%) in Germany in 1991 to that in 2004?
Provide a short and direct response. 0.99. What is the ratio of the Gross enrolment ratio (%) in Israel in 1991 to that in 2004?
Ensure brevity in your answer.  0.86. What is the ratio of the Gross enrolment ratio (%) in Norway in 1991 to that in 2004?
Offer a terse response. 0.89. What is the ratio of the Gross enrolment ratio (%) of Congo (Republic) in 1991 to that in 2012?
Give a very brief answer. 0.89. What is the ratio of the Gross enrolment ratio (%) of Germany in 1991 to that in 2012?
Ensure brevity in your answer.  0.97. What is the ratio of the Gross enrolment ratio (%) of Israel in 1991 to that in 2012?
Ensure brevity in your answer.  0.89. What is the ratio of the Gross enrolment ratio (%) in Norway in 1991 to that in 2012?
Give a very brief answer. 0.93. What is the ratio of the Gross enrolment ratio (%) of Congo (Republic) in 1992 to that in 1994?
Make the answer very short. 0.95. What is the ratio of the Gross enrolment ratio (%) of Germany in 1992 to that in 1994?
Provide a succinct answer. 0.96. What is the ratio of the Gross enrolment ratio (%) in Israel in 1992 to that in 1994?
Your answer should be compact. 1.02. What is the ratio of the Gross enrolment ratio (%) in Norway in 1992 to that in 1994?
Make the answer very short. 0.85. What is the ratio of the Gross enrolment ratio (%) of Germany in 1992 to that in 1996?
Your answer should be compact. 0.98. What is the ratio of the Gross enrolment ratio (%) of Israel in 1992 to that in 1996?
Give a very brief answer. 1.03. What is the ratio of the Gross enrolment ratio (%) of Norway in 1992 to that in 1996?
Keep it short and to the point. 0.91. What is the ratio of the Gross enrolment ratio (%) in Congo (Republic) in 1992 to that in 2002?
Your response must be concise. 1.24. What is the ratio of the Gross enrolment ratio (%) in Germany in 1992 to that in 2002?
Give a very brief answer. 1.01. What is the ratio of the Gross enrolment ratio (%) of Israel in 1992 to that in 2002?
Your response must be concise. 0.87. What is the ratio of the Gross enrolment ratio (%) of Norway in 1992 to that in 2002?
Your answer should be very brief. 0.94. What is the ratio of the Gross enrolment ratio (%) of Congo (Republic) in 1992 to that in 2003?
Provide a short and direct response. 1.2. What is the ratio of the Gross enrolment ratio (%) of Israel in 1992 to that in 2003?
Offer a terse response. 0.87. What is the ratio of the Gross enrolment ratio (%) of Norway in 1992 to that in 2003?
Ensure brevity in your answer.  0.93. What is the ratio of the Gross enrolment ratio (%) of Congo (Republic) in 1992 to that in 2004?
Your answer should be compact. 1.06. What is the ratio of the Gross enrolment ratio (%) of Israel in 1992 to that in 2004?
Provide a short and direct response. 0.88. What is the ratio of the Gross enrolment ratio (%) of Norway in 1992 to that in 2004?
Give a very brief answer. 0.91. What is the ratio of the Gross enrolment ratio (%) of Congo (Republic) in 1992 to that in 2012?
Ensure brevity in your answer.  0.9. What is the ratio of the Gross enrolment ratio (%) of Germany in 1992 to that in 2012?
Ensure brevity in your answer.  0.98. What is the ratio of the Gross enrolment ratio (%) of Israel in 1992 to that in 2012?
Your answer should be compact. 0.91. What is the ratio of the Gross enrolment ratio (%) in Congo (Republic) in 1994 to that in 1996?
Provide a short and direct response. 1.04. What is the ratio of the Gross enrolment ratio (%) in Germany in 1994 to that in 1996?
Keep it short and to the point. 1.02. What is the ratio of the Gross enrolment ratio (%) of Israel in 1994 to that in 1996?
Offer a terse response. 1.01. What is the ratio of the Gross enrolment ratio (%) of Norway in 1994 to that in 1996?
Provide a short and direct response. 1.08. What is the ratio of the Gross enrolment ratio (%) in Congo (Republic) in 1994 to that in 2002?
Ensure brevity in your answer.  1.3. What is the ratio of the Gross enrolment ratio (%) of Germany in 1994 to that in 2002?
Make the answer very short. 1.05. What is the ratio of the Gross enrolment ratio (%) in Israel in 1994 to that in 2002?
Keep it short and to the point. 0.85. What is the ratio of the Gross enrolment ratio (%) in Norway in 1994 to that in 2002?
Give a very brief answer. 1.11. What is the ratio of the Gross enrolment ratio (%) in Congo (Republic) in 1994 to that in 2003?
Ensure brevity in your answer.  1.26. What is the ratio of the Gross enrolment ratio (%) in Germany in 1994 to that in 2003?
Your answer should be very brief. 1.04. What is the ratio of the Gross enrolment ratio (%) in Israel in 1994 to that in 2003?
Keep it short and to the point. 0.86. What is the ratio of the Gross enrolment ratio (%) of Norway in 1994 to that in 2003?
Offer a very short reply. 1.1. What is the ratio of the Gross enrolment ratio (%) of Congo (Republic) in 1994 to that in 2004?
Ensure brevity in your answer.  1.11. What is the ratio of the Gross enrolment ratio (%) of Germany in 1994 to that in 2004?
Your response must be concise. 1.04. What is the ratio of the Gross enrolment ratio (%) of Israel in 1994 to that in 2004?
Ensure brevity in your answer.  0.86. What is the ratio of the Gross enrolment ratio (%) of Norway in 1994 to that in 2004?
Your response must be concise. 1.08. What is the ratio of the Gross enrolment ratio (%) in Congo (Republic) in 1994 to that in 2012?
Keep it short and to the point. 0.94. What is the ratio of the Gross enrolment ratio (%) in Germany in 1994 to that in 2012?
Offer a terse response. 1.02. What is the ratio of the Gross enrolment ratio (%) of Israel in 1994 to that in 2012?
Ensure brevity in your answer.  0.89. What is the ratio of the Gross enrolment ratio (%) in Norway in 1994 to that in 2012?
Your response must be concise. 1.12. What is the ratio of the Gross enrolment ratio (%) in Congo (Republic) in 1996 to that in 2002?
Give a very brief answer. 1.25. What is the ratio of the Gross enrolment ratio (%) of Germany in 1996 to that in 2002?
Your response must be concise. 1.03. What is the ratio of the Gross enrolment ratio (%) of Israel in 1996 to that in 2002?
Keep it short and to the point. 0.84. What is the ratio of the Gross enrolment ratio (%) of Norway in 1996 to that in 2002?
Your answer should be compact. 1.03. What is the ratio of the Gross enrolment ratio (%) of Congo (Republic) in 1996 to that in 2003?
Provide a succinct answer. 1.21. What is the ratio of the Gross enrolment ratio (%) in Germany in 1996 to that in 2003?
Provide a short and direct response. 1.03. What is the ratio of the Gross enrolment ratio (%) in Israel in 1996 to that in 2003?
Ensure brevity in your answer.  0.85. What is the ratio of the Gross enrolment ratio (%) in Norway in 1996 to that in 2003?
Give a very brief answer. 1.02. What is the ratio of the Gross enrolment ratio (%) in Congo (Republic) in 1996 to that in 2004?
Your response must be concise. 1.06. What is the ratio of the Gross enrolment ratio (%) in Israel in 1996 to that in 2004?
Keep it short and to the point. 0.86. What is the ratio of the Gross enrolment ratio (%) of Norway in 1996 to that in 2004?
Offer a very short reply. 1. What is the ratio of the Gross enrolment ratio (%) of Congo (Republic) in 1996 to that in 2012?
Your answer should be very brief. 0.9. What is the ratio of the Gross enrolment ratio (%) in Israel in 1996 to that in 2012?
Your answer should be compact. 0.88. What is the ratio of the Gross enrolment ratio (%) in Norway in 1996 to that in 2012?
Provide a short and direct response. 1.04. What is the ratio of the Gross enrolment ratio (%) in Congo (Republic) in 2002 to that in 2003?
Give a very brief answer. 0.97. What is the ratio of the Gross enrolment ratio (%) in Israel in 2002 to that in 2003?
Provide a succinct answer. 1.01. What is the ratio of the Gross enrolment ratio (%) in Congo (Republic) in 2002 to that in 2004?
Make the answer very short. 0.85. What is the ratio of the Gross enrolment ratio (%) of Israel in 2002 to that in 2004?
Give a very brief answer. 1.01. What is the ratio of the Gross enrolment ratio (%) of Norway in 2002 to that in 2004?
Give a very brief answer. 0.97. What is the ratio of the Gross enrolment ratio (%) of Congo (Republic) in 2002 to that in 2012?
Offer a terse response. 0.72. What is the ratio of the Gross enrolment ratio (%) of Germany in 2002 to that in 2012?
Your answer should be very brief. 0.97. What is the ratio of the Gross enrolment ratio (%) of Israel in 2002 to that in 2012?
Provide a succinct answer. 1.05. What is the ratio of the Gross enrolment ratio (%) in Norway in 2002 to that in 2012?
Offer a terse response. 1.01. What is the ratio of the Gross enrolment ratio (%) of Congo (Republic) in 2003 to that in 2004?
Your answer should be very brief. 0.88. What is the ratio of the Gross enrolment ratio (%) in Israel in 2003 to that in 2004?
Provide a succinct answer. 1.01. What is the ratio of the Gross enrolment ratio (%) of Norway in 2003 to that in 2004?
Offer a terse response. 0.98. What is the ratio of the Gross enrolment ratio (%) in Congo (Republic) in 2003 to that in 2012?
Offer a terse response. 0.75. What is the ratio of the Gross enrolment ratio (%) of Germany in 2003 to that in 2012?
Offer a terse response. 0.97. What is the ratio of the Gross enrolment ratio (%) of Israel in 2003 to that in 2012?
Offer a terse response. 1.04. What is the ratio of the Gross enrolment ratio (%) of Norway in 2003 to that in 2012?
Your answer should be compact. 1.02. What is the ratio of the Gross enrolment ratio (%) in Congo (Republic) in 2004 to that in 2012?
Your answer should be compact. 0.85. What is the ratio of the Gross enrolment ratio (%) of Germany in 2004 to that in 2012?
Offer a very short reply. 0.98. What is the ratio of the Gross enrolment ratio (%) of Israel in 2004 to that in 2012?
Offer a terse response. 1.03. What is the ratio of the Gross enrolment ratio (%) of Norway in 2004 to that in 2012?
Provide a succinct answer. 1.04. What is the difference between the highest and the second highest Gross enrolment ratio (%) in Congo (Republic)?
Offer a very short reply. 2.97. What is the difference between the highest and the second highest Gross enrolment ratio (%) of Germany?
Provide a short and direct response. 1.61. What is the difference between the highest and the second highest Gross enrolment ratio (%) in Israel?
Provide a short and direct response. 0.6. What is the difference between the highest and the second highest Gross enrolment ratio (%) in Norway?
Your answer should be very brief. 9.1. What is the difference between the highest and the lowest Gross enrolment ratio (%) of Congo (Republic)?
Your answer should be very brief. 14.79. What is the difference between the highest and the lowest Gross enrolment ratio (%) of Germany?
Make the answer very short. 4.84. What is the difference between the highest and the lowest Gross enrolment ratio (%) of Israel?
Your answer should be compact. 16.5. What is the difference between the highest and the lowest Gross enrolment ratio (%) of Norway?
Your response must be concise. 21.81. 